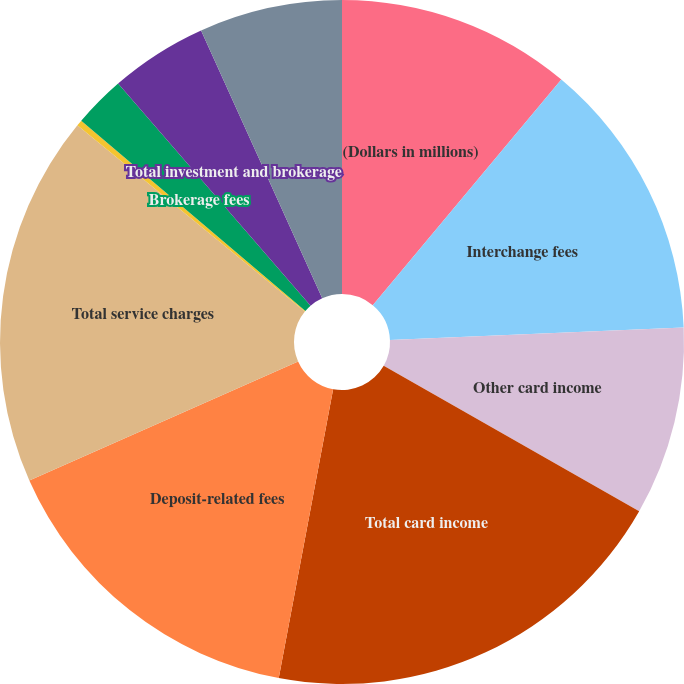Convert chart to OTSL. <chart><loc_0><loc_0><loc_500><loc_500><pie_chart><fcel>(Dollars in millions)<fcel>Interchange fees<fcel>Other card income<fcel>Total card income<fcel>Deposit-related fees<fcel>Total service charges<fcel>Asset management fees<fcel>Brokerage fees<fcel>Total investment and brokerage<fcel>Other income<nl><fcel>11.08%<fcel>13.24%<fcel>8.92%<fcel>19.72%<fcel>15.4%<fcel>17.56%<fcel>0.28%<fcel>2.44%<fcel>4.6%<fcel>6.76%<nl></chart> 